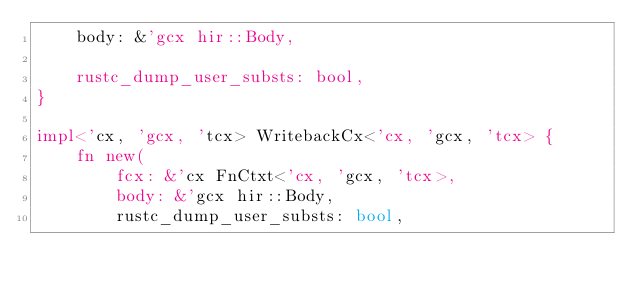<code> <loc_0><loc_0><loc_500><loc_500><_Rust_>    body: &'gcx hir::Body,

    rustc_dump_user_substs: bool,
}

impl<'cx, 'gcx, 'tcx> WritebackCx<'cx, 'gcx, 'tcx> {
    fn new(
        fcx: &'cx FnCtxt<'cx, 'gcx, 'tcx>,
        body: &'gcx hir::Body,
        rustc_dump_user_substs: bool,</code> 